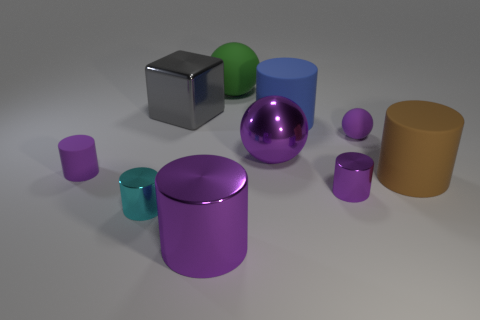Subtract 0 red balls. How many objects are left? 10 Subtract all cylinders. How many objects are left? 4 Subtract 1 balls. How many balls are left? 2 Subtract all blue spheres. Subtract all cyan blocks. How many spheres are left? 3 Subtract all purple spheres. How many cyan cylinders are left? 1 Subtract all tiny brown matte balls. Subtract all large blue objects. How many objects are left? 9 Add 7 large brown cylinders. How many large brown cylinders are left? 8 Add 5 big metal objects. How many big metal objects exist? 8 Subtract all purple spheres. How many spheres are left? 1 Subtract all blue cylinders. How many cylinders are left? 5 